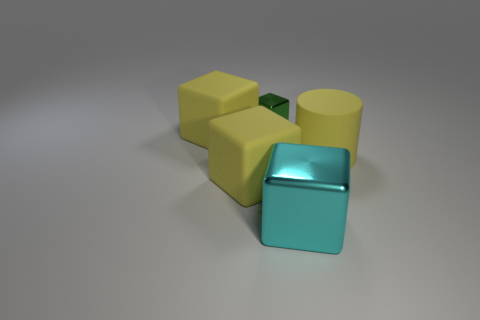There is a cyan thing that is the same size as the yellow cylinder; what is its material? The cyan object appears to be made of a shiny, reflective material, similar to polished metal or plastic with a metallic finish. Its surface has a smooth texture and a glossy sheen indicative of such materials. 